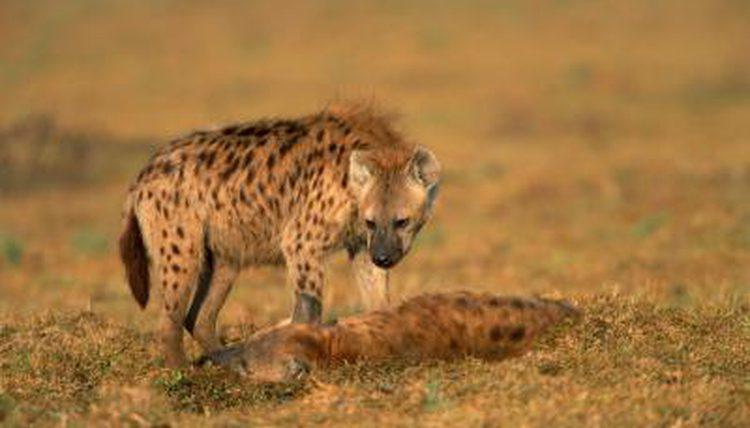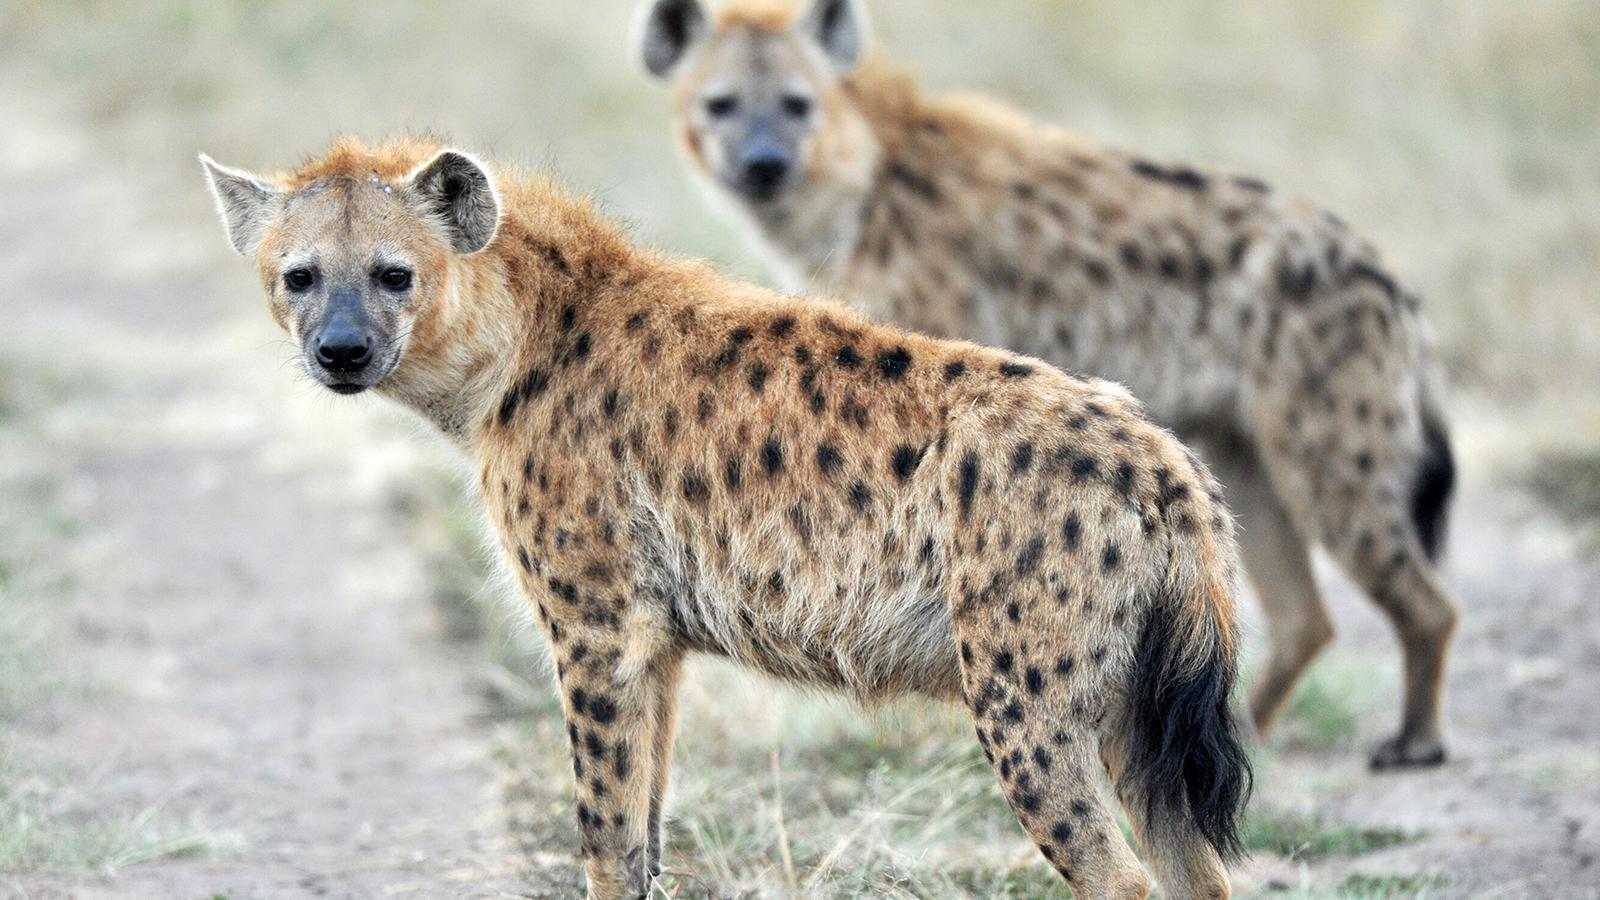The first image is the image on the left, the second image is the image on the right. Evaluate the accuracy of this statement regarding the images: "There are hyena cubs laying with their moms". Is it true? Answer yes or no. No. The first image is the image on the left, the second image is the image on the right. Considering the images on both sides, is "An image shows an adult hyena lying with a much younger hyena." valid? Answer yes or no. No. The first image is the image on the left, the second image is the image on the right. Examine the images to the left and right. Is the description "There are exactly two hyenas in the image on the right." accurate? Answer yes or no. Yes. The first image is the image on the left, the second image is the image on the right. Examine the images to the left and right. Is the description "There are exactly two hyenas in each image." accurate? Answer yes or no. Yes. 